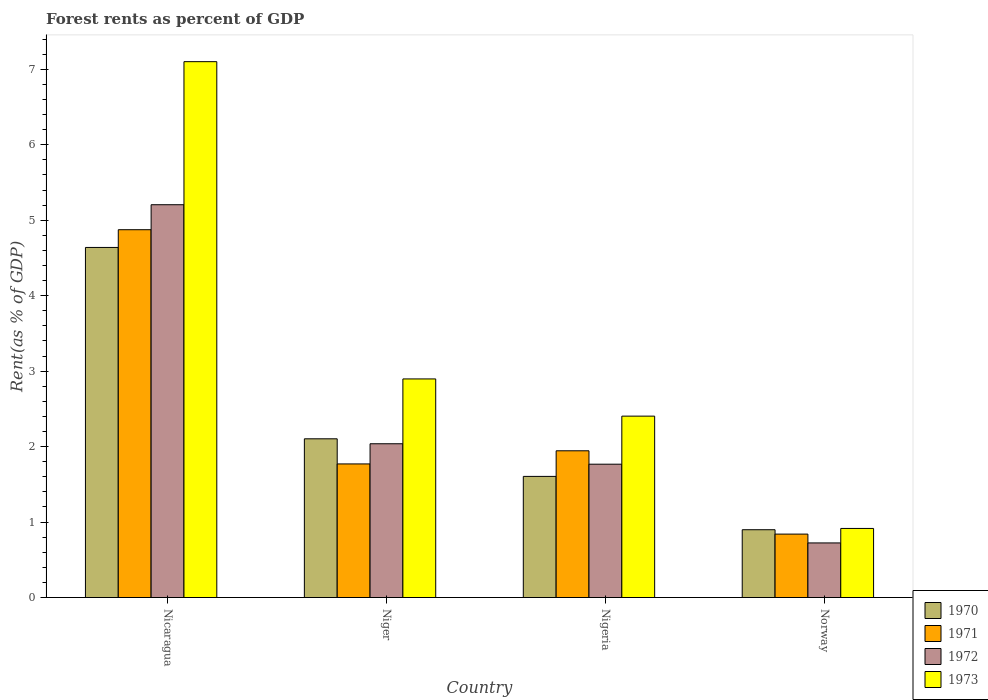How many different coloured bars are there?
Keep it short and to the point. 4. Are the number of bars per tick equal to the number of legend labels?
Ensure brevity in your answer.  Yes. Are the number of bars on each tick of the X-axis equal?
Provide a short and direct response. Yes. How many bars are there on the 3rd tick from the right?
Ensure brevity in your answer.  4. What is the label of the 2nd group of bars from the left?
Offer a terse response. Niger. What is the forest rent in 1972 in Nicaragua?
Ensure brevity in your answer.  5.21. Across all countries, what is the maximum forest rent in 1972?
Offer a terse response. 5.21. Across all countries, what is the minimum forest rent in 1970?
Ensure brevity in your answer.  0.9. In which country was the forest rent in 1970 maximum?
Offer a terse response. Nicaragua. What is the total forest rent in 1971 in the graph?
Keep it short and to the point. 9.43. What is the difference between the forest rent in 1971 in Nigeria and that in Norway?
Provide a short and direct response. 1.1. What is the difference between the forest rent in 1973 in Nicaragua and the forest rent in 1970 in Niger?
Ensure brevity in your answer.  5. What is the average forest rent in 1973 per country?
Offer a very short reply. 3.33. What is the difference between the forest rent of/in 1971 and forest rent of/in 1973 in Nigeria?
Keep it short and to the point. -0.46. In how many countries, is the forest rent in 1970 greater than 3.4 %?
Offer a terse response. 1. What is the ratio of the forest rent in 1970 in Nicaragua to that in Nigeria?
Ensure brevity in your answer.  2.89. Is the forest rent in 1972 in Nicaragua less than that in Norway?
Your response must be concise. No. Is the difference between the forest rent in 1971 in Niger and Nigeria greater than the difference between the forest rent in 1973 in Niger and Nigeria?
Provide a succinct answer. No. What is the difference between the highest and the second highest forest rent in 1971?
Offer a terse response. -2.93. What is the difference between the highest and the lowest forest rent in 1973?
Offer a terse response. 6.19. In how many countries, is the forest rent in 1972 greater than the average forest rent in 1972 taken over all countries?
Your answer should be very brief. 1. Is the sum of the forest rent in 1973 in Nicaragua and Norway greater than the maximum forest rent in 1971 across all countries?
Your answer should be very brief. Yes. What does the 1st bar from the left in Niger represents?
Offer a very short reply. 1970. What does the 4th bar from the right in Niger represents?
Your answer should be very brief. 1970. How many bars are there?
Provide a succinct answer. 16. What is the title of the graph?
Provide a succinct answer. Forest rents as percent of GDP. Does "1991" appear as one of the legend labels in the graph?
Your answer should be compact. No. What is the label or title of the Y-axis?
Provide a short and direct response. Rent(as % of GDP). What is the Rent(as % of GDP) in 1970 in Nicaragua?
Ensure brevity in your answer.  4.64. What is the Rent(as % of GDP) of 1971 in Nicaragua?
Your response must be concise. 4.87. What is the Rent(as % of GDP) in 1972 in Nicaragua?
Provide a short and direct response. 5.21. What is the Rent(as % of GDP) of 1973 in Nicaragua?
Offer a terse response. 7.1. What is the Rent(as % of GDP) of 1970 in Niger?
Ensure brevity in your answer.  2.1. What is the Rent(as % of GDP) of 1971 in Niger?
Offer a terse response. 1.77. What is the Rent(as % of GDP) of 1972 in Niger?
Keep it short and to the point. 2.04. What is the Rent(as % of GDP) in 1973 in Niger?
Provide a short and direct response. 2.9. What is the Rent(as % of GDP) in 1970 in Nigeria?
Give a very brief answer. 1.61. What is the Rent(as % of GDP) in 1971 in Nigeria?
Make the answer very short. 1.94. What is the Rent(as % of GDP) of 1972 in Nigeria?
Give a very brief answer. 1.77. What is the Rent(as % of GDP) in 1973 in Nigeria?
Your answer should be very brief. 2.4. What is the Rent(as % of GDP) in 1970 in Norway?
Give a very brief answer. 0.9. What is the Rent(as % of GDP) in 1971 in Norway?
Offer a very short reply. 0.84. What is the Rent(as % of GDP) in 1972 in Norway?
Give a very brief answer. 0.72. What is the Rent(as % of GDP) in 1973 in Norway?
Your response must be concise. 0.92. Across all countries, what is the maximum Rent(as % of GDP) of 1970?
Give a very brief answer. 4.64. Across all countries, what is the maximum Rent(as % of GDP) of 1971?
Your response must be concise. 4.87. Across all countries, what is the maximum Rent(as % of GDP) of 1972?
Ensure brevity in your answer.  5.21. Across all countries, what is the maximum Rent(as % of GDP) of 1973?
Give a very brief answer. 7.1. Across all countries, what is the minimum Rent(as % of GDP) of 1970?
Ensure brevity in your answer.  0.9. Across all countries, what is the minimum Rent(as % of GDP) of 1971?
Provide a succinct answer. 0.84. Across all countries, what is the minimum Rent(as % of GDP) of 1972?
Make the answer very short. 0.72. Across all countries, what is the minimum Rent(as % of GDP) of 1973?
Give a very brief answer. 0.92. What is the total Rent(as % of GDP) of 1970 in the graph?
Provide a succinct answer. 9.25. What is the total Rent(as % of GDP) of 1971 in the graph?
Provide a succinct answer. 9.43. What is the total Rent(as % of GDP) of 1972 in the graph?
Give a very brief answer. 9.73. What is the total Rent(as % of GDP) in 1973 in the graph?
Keep it short and to the point. 13.32. What is the difference between the Rent(as % of GDP) in 1970 in Nicaragua and that in Niger?
Your answer should be very brief. 2.54. What is the difference between the Rent(as % of GDP) of 1971 in Nicaragua and that in Niger?
Ensure brevity in your answer.  3.1. What is the difference between the Rent(as % of GDP) in 1972 in Nicaragua and that in Niger?
Ensure brevity in your answer.  3.17. What is the difference between the Rent(as % of GDP) of 1973 in Nicaragua and that in Niger?
Make the answer very short. 4.2. What is the difference between the Rent(as % of GDP) of 1970 in Nicaragua and that in Nigeria?
Make the answer very short. 3.03. What is the difference between the Rent(as % of GDP) in 1971 in Nicaragua and that in Nigeria?
Give a very brief answer. 2.93. What is the difference between the Rent(as % of GDP) of 1972 in Nicaragua and that in Nigeria?
Provide a short and direct response. 3.44. What is the difference between the Rent(as % of GDP) in 1973 in Nicaragua and that in Nigeria?
Your answer should be compact. 4.7. What is the difference between the Rent(as % of GDP) of 1970 in Nicaragua and that in Norway?
Provide a short and direct response. 3.74. What is the difference between the Rent(as % of GDP) in 1971 in Nicaragua and that in Norway?
Give a very brief answer. 4.03. What is the difference between the Rent(as % of GDP) in 1972 in Nicaragua and that in Norway?
Your response must be concise. 4.48. What is the difference between the Rent(as % of GDP) of 1973 in Nicaragua and that in Norway?
Offer a terse response. 6.19. What is the difference between the Rent(as % of GDP) in 1970 in Niger and that in Nigeria?
Provide a short and direct response. 0.5. What is the difference between the Rent(as % of GDP) in 1971 in Niger and that in Nigeria?
Ensure brevity in your answer.  -0.17. What is the difference between the Rent(as % of GDP) of 1972 in Niger and that in Nigeria?
Ensure brevity in your answer.  0.27. What is the difference between the Rent(as % of GDP) of 1973 in Niger and that in Nigeria?
Your answer should be very brief. 0.49. What is the difference between the Rent(as % of GDP) in 1970 in Niger and that in Norway?
Provide a succinct answer. 1.21. What is the difference between the Rent(as % of GDP) of 1972 in Niger and that in Norway?
Your response must be concise. 1.31. What is the difference between the Rent(as % of GDP) of 1973 in Niger and that in Norway?
Provide a succinct answer. 1.98. What is the difference between the Rent(as % of GDP) of 1970 in Nigeria and that in Norway?
Your answer should be compact. 0.71. What is the difference between the Rent(as % of GDP) in 1971 in Nigeria and that in Norway?
Provide a succinct answer. 1.1. What is the difference between the Rent(as % of GDP) of 1972 in Nigeria and that in Norway?
Your answer should be very brief. 1.04. What is the difference between the Rent(as % of GDP) in 1973 in Nigeria and that in Norway?
Your answer should be compact. 1.49. What is the difference between the Rent(as % of GDP) of 1970 in Nicaragua and the Rent(as % of GDP) of 1971 in Niger?
Make the answer very short. 2.87. What is the difference between the Rent(as % of GDP) in 1970 in Nicaragua and the Rent(as % of GDP) in 1972 in Niger?
Your answer should be very brief. 2.6. What is the difference between the Rent(as % of GDP) in 1970 in Nicaragua and the Rent(as % of GDP) in 1973 in Niger?
Make the answer very short. 1.74. What is the difference between the Rent(as % of GDP) in 1971 in Nicaragua and the Rent(as % of GDP) in 1972 in Niger?
Make the answer very short. 2.84. What is the difference between the Rent(as % of GDP) of 1971 in Nicaragua and the Rent(as % of GDP) of 1973 in Niger?
Your response must be concise. 1.98. What is the difference between the Rent(as % of GDP) in 1972 in Nicaragua and the Rent(as % of GDP) in 1973 in Niger?
Your response must be concise. 2.31. What is the difference between the Rent(as % of GDP) in 1970 in Nicaragua and the Rent(as % of GDP) in 1971 in Nigeria?
Provide a short and direct response. 2.69. What is the difference between the Rent(as % of GDP) of 1970 in Nicaragua and the Rent(as % of GDP) of 1972 in Nigeria?
Offer a terse response. 2.87. What is the difference between the Rent(as % of GDP) of 1970 in Nicaragua and the Rent(as % of GDP) of 1973 in Nigeria?
Your answer should be very brief. 2.24. What is the difference between the Rent(as % of GDP) in 1971 in Nicaragua and the Rent(as % of GDP) in 1972 in Nigeria?
Keep it short and to the point. 3.11. What is the difference between the Rent(as % of GDP) in 1971 in Nicaragua and the Rent(as % of GDP) in 1973 in Nigeria?
Ensure brevity in your answer.  2.47. What is the difference between the Rent(as % of GDP) in 1972 in Nicaragua and the Rent(as % of GDP) in 1973 in Nigeria?
Provide a short and direct response. 2.8. What is the difference between the Rent(as % of GDP) in 1970 in Nicaragua and the Rent(as % of GDP) in 1971 in Norway?
Provide a short and direct response. 3.8. What is the difference between the Rent(as % of GDP) in 1970 in Nicaragua and the Rent(as % of GDP) in 1972 in Norway?
Ensure brevity in your answer.  3.92. What is the difference between the Rent(as % of GDP) of 1970 in Nicaragua and the Rent(as % of GDP) of 1973 in Norway?
Offer a very short reply. 3.72. What is the difference between the Rent(as % of GDP) in 1971 in Nicaragua and the Rent(as % of GDP) in 1972 in Norway?
Provide a short and direct response. 4.15. What is the difference between the Rent(as % of GDP) of 1971 in Nicaragua and the Rent(as % of GDP) of 1973 in Norway?
Give a very brief answer. 3.96. What is the difference between the Rent(as % of GDP) in 1972 in Nicaragua and the Rent(as % of GDP) in 1973 in Norway?
Provide a succinct answer. 4.29. What is the difference between the Rent(as % of GDP) in 1970 in Niger and the Rent(as % of GDP) in 1971 in Nigeria?
Keep it short and to the point. 0.16. What is the difference between the Rent(as % of GDP) in 1970 in Niger and the Rent(as % of GDP) in 1972 in Nigeria?
Ensure brevity in your answer.  0.34. What is the difference between the Rent(as % of GDP) of 1970 in Niger and the Rent(as % of GDP) of 1973 in Nigeria?
Give a very brief answer. -0.3. What is the difference between the Rent(as % of GDP) of 1971 in Niger and the Rent(as % of GDP) of 1972 in Nigeria?
Your answer should be very brief. 0. What is the difference between the Rent(as % of GDP) in 1971 in Niger and the Rent(as % of GDP) in 1973 in Nigeria?
Your answer should be compact. -0.63. What is the difference between the Rent(as % of GDP) in 1972 in Niger and the Rent(as % of GDP) in 1973 in Nigeria?
Ensure brevity in your answer.  -0.37. What is the difference between the Rent(as % of GDP) in 1970 in Niger and the Rent(as % of GDP) in 1971 in Norway?
Your answer should be compact. 1.26. What is the difference between the Rent(as % of GDP) of 1970 in Niger and the Rent(as % of GDP) of 1972 in Norway?
Offer a very short reply. 1.38. What is the difference between the Rent(as % of GDP) of 1970 in Niger and the Rent(as % of GDP) of 1973 in Norway?
Your answer should be compact. 1.19. What is the difference between the Rent(as % of GDP) in 1971 in Niger and the Rent(as % of GDP) in 1972 in Norway?
Provide a succinct answer. 1.05. What is the difference between the Rent(as % of GDP) of 1971 in Niger and the Rent(as % of GDP) of 1973 in Norway?
Ensure brevity in your answer.  0.85. What is the difference between the Rent(as % of GDP) in 1972 in Niger and the Rent(as % of GDP) in 1973 in Norway?
Offer a very short reply. 1.12. What is the difference between the Rent(as % of GDP) in 1970 in Nigeria and the Rent(as % of GDP) in 1971 in Norway?
Your response must be concise. 0.76. What is the difference between the Rent(as % of GDP) in 1970 in Nigeria and the Rent(as % of GDP) in 1972 in Norway?
Offer a very short reply. 0.88. What is the difference between the Rent(as % of GDP) of 1970 in Nigeria and the Rent(as % of GDP) of 1973 in Norway?
Offer a terse response. 0.69. What is the difference between the Rent(as % of GDP) in 1971 in Nigeria and the Rent(as % of GDP) in 1972 in Norway?
Keep it short and to the point. 1.22. What is the difference between the Rent(as % of GDP) of 1971 in Nigeria and the Rent(as % of GDP) of 1973 in Norway?
Make the answer very short. 1.03. What is the difference between the Rent(as % of GDP) of 1972 in Nigeria and the Rent(as % of GDP) of 1973 in Norway?
Offer a very short reply. 0.85. What is the average Rent(as % of GDP) in 1970 per country?
Offer a terse response. 2.31. What is the average Rent(as % of GDP) of 1971 per country?
Your answer should be very brief. 2.36. What is the average Rent(as % of GDP) of 1972 per country?
Your response must be concise. 2.43. What is the average Rent(as % of GDP) of 1973 per country?
Offer a very short reply. 3.33. What is the difference between the Rent(as % of GDP) in 1970 and Rent(as % of GDP) in 1971 in Nicaragua?
Provide a short and direct response. -0.23. What is the difference between the Rent(as % of GDP) of 1970 and Rent(as % of GDP) of 1972 in Nicaragua?
Offer a terse response. -0.57. What is the difference between the Rent(as % of GDP) in 1970 and Rent(as % of GDP) in 1973 in Nicaragua?
Make the answer very short. -2.46. What is the difference between the Rent(as % of GDP) in 1971 and Rent(as % of GDP) in 1972 in Nicaragua?
Give a very brief answer. -0.33. What is the difference between the Rent(as % of GDP) of 1971 and Rent(as % of GDP) of 1973 in Nicaragua?
Give a very brief answer. -2.23. What is the difference between the Rent(as % of GDP) in 1972 and Rent(as % of GDP) in 1973 in Nicaragua?
Keep it short and to the point. -1.9. What is the difference between the Rent(as % of GDP) of 1970 and Rent(as % of GDP) of 1971 in Niger?
Ensure brevity in your answer.  0.33. What is the difference between the Rent(as % of GDP) of 1970 and Rent(as % of GDP) of 1972 in Niger?
Make the answer very short. 0.07. What is the difference between the Rent(as % of GDP) of 1970 and Rent(as % of GDP) of 1973 in Niger?
Make the answer very short. -0.79. What is the difference between the Rent(as % of GDP) of 1971 and Rent(as % of GDP) of 1972 in Niger?
Provide a short and direct response. -0.27. What is the difference between the Rent(as % of GDP) of 1971 and Rent(as % of GDP) of 1973 in Niger?
Your answer should be very brief. -1.13. What is the difference between the Rent(as % of GDP) of 1972 and Rent(as % of GDP) of 1973 in Niger?
Provide a short and direct response. -0.86. What is the difference between the Rent(as % of GDP) of 1970 and Rent(as % of GDP) of 1971 in Nigeria?
Your answer should be compact. -0.34. What is the difference between the Rent(as % of GDP) in 1970 and Rent(as % of GDP) in 1972 in Nigeria?
Keep it short and to the point. -0.16. What is the difference between the Rent(as % of GDP) of 1970 and Rent(as % of GDP) of 1973 in Nigeria?
Provide a short and direct response. -0.8. What is the difference between the Rent(as % of GDP) in 1971 and Rent(as % of GDP) in 1972 in Nigeria?
Provide a short and direct response. 0.18. What is the difference between the Rent(as % of GDP) of 1971 and Rent(as % of GDP) of 1973 in Nigeria?
Provide a succinct answer. -0.46. What is the difference between the Rent(as % of GDP) in 1972 and Rent(as % of GDP) in 1973 in Nigeria?
Your response must be concise. -0.64. What is the difference between the Rent(as % of GDP) in 1970 and Rent(as % of GDP) in 1971 in Norway?
Your response must be concise. 0.06. What is the difference between the Rent(as % of GDP) of 1970 and Rent(as % of GDP) of 1972 in Norway?
Provide a succinct answer. 0.17. What is the difference between the Rent(as % of GDP) in 1970 and Rent(as % of GDP) in 1973 in Norway?
Keep it short and to the point. -0.02. What is the difference between the Rent(as % of GDP) in 1971 and Rent(as % of GDP) in 1972 in Norway?
Make the answer very short. 0.12. What is the difference between the Rent(as % of GDP) in 1971 and Rent(as % of GDP) in 1973 in Norway?
Provide a succinct answer. -0.08. What is the difference between the Rent(as % of GDP) of 1972 and Rent(as % of GDP) of 1973 in Norway?
Provide a succinct answer. -0.19. What is the ratio of the Rent(as % of GDP) in 1970 in Nicaragua to that in Niger?
Make the answer very short. 2.21. What is the ratio of the Rent(as % of GDP) of 1971 in Nicaragua to that in Niger?
Offer a terse response. 2.75. What is the ratio of the Rent(as % of GDP) of 1972 in Nicaragua to that in Niger?
Your answer should be compact. 2.55. What is the ratio of the Rent(as % of GDP) of 1973 in Nicaragua to that in Niger?
Provide a short and direct response. 2.45. What is the ratio of the Rent(as % of GDP) in 1970 in Nicaragua to that in Nigeria?
Your answer should be very brief. 2.89. What is the ratio of the Rent(as % of GDP) of 1971 in Nicaragua to that in Nigeria?
Offer a very short reply. 2.51. What is the ratio of the Rent(as % of GDP) of 1972 in Nicaragua to that in Nigeria?
Make the answer very short. 2.95. What is the ratio of the Rent(as % of GDP) in 1973 in Nicaragua to that in Nigeria?
Give a very brief answer. 2.95. What is the ratio of the Rent(as % of GDP) in 1970 in Nicaragua to that in Norway?
Provide a short and direct response. 5.16. What is the ratio of the Rent(as % of GDP) of 1971 in Nicaragua to that in Norway?
Provide a succinct answer. 5.8. What is the ratio of the Rent(as % of GDP) in 1972 in Nicaragua to that in Norway?
Offer a terse response. 7.19. What is the ratio of the Rent(as % of GDP) of 1973 in Nicaragua to that in Norway?
Your answer should be compact. 7.76. What is the ratio of the Rent(as % of GDP) in 1970 in Niger to that in Nigeria?
Provide a succinct answer. 1.31. What is the ratio of the Rent(as % of GDP) of 1971 in Niger to that in Nigeria?
Your answer should be very brief. 0.91. What is the ratio of the Rent(as % of GDP) of 1972 in Niger to that in Nigeria?
Ensure brevity in your answer.  1.15. What is the ratio of the Rent(as % of GDP) in 1973 in Niger to that in Nigeria?
Your answer should be very brief. 1.21. What is the ratio of the Rent(as % of GDP) in 1970 in Niger to that in Norway?
Your response must be concise. 2.34. What is the ratio of the Rent(as % of GDP) in 1971 in Niger to that in Norway?
Provide a short and direct response. 2.11. What is the ratio of the Rent(as % of GDP) of 1972 in Niger to that in Norway?
Your answer should be very brief. 2.82. What is the ratio of the Rent(as % of GDP) of 1973 in Niger to that in Norway?
Provide a succinct answer. 3.16. What is the ratio of the Rent(as % of GDP) in 1970 in Nigeria to that in Norway?
Offer a terse response. 1.79. What is the ratio of the Rent(as % of GDP) in 1971 in Nigeria to that in Norway?
Provide a short and direct response. 2.31. What is the ratio of the Rent(as % of GDP) of 1972 in Nigeria to that in Norway?
Offer a terse response. 2.44. What is the ratio of the Rent(as % of GDP) of 1973 in Nigeria to that in Norway?
Offer a very short reply. 2.63. What is the difference between the highest and the second highest Rent(as % of GDP) in 1970?
Offer a very short reply. 2.54. What is the difference between the highest and the second highest Rent(as % of GDP) of 1971?
Offer a very short reply. 2.93. What is the difference between the highest and the second highest Rent(as % of GDP) of 1972?
Offer a very short reply. 3.17. What is the difference between the highest and the second highest Rent(as % of GDP) of 1973?
Ensure brevity in your answer.  4.2. What is the difference between the highest and the lowest Rent(as % of GDP) of 1970?
Your answer should be compact. 3.74. What is the difference between the highest and the lowest Rent(as % of GDP) of 1971?
Your answer should be compact. 4.03. What is the difference between the highest and the lowest Rent(as % of GDP) of 1972?
Ensure brevity in your answer.  4.48. What is the difference between the highest and the lowest Rent(as % of GDP) of 1973?
Offer a very short reply. 6.19. 